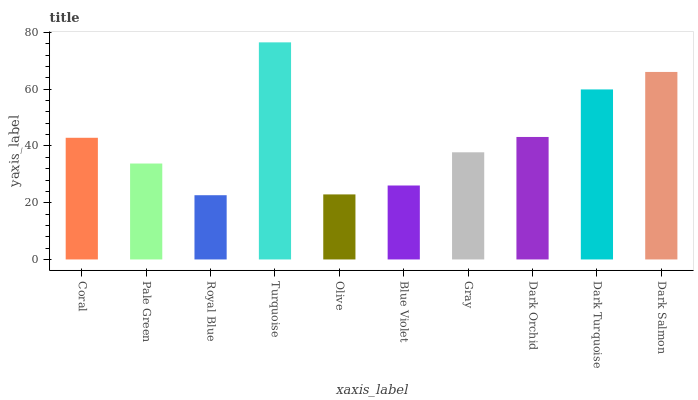Is Royal Blue the minimum?
Answer yes or no. Yes. Is Turquoise the maximum?
Answer yes or no. Yes. Is Pale Green the minimum?
Answer yes or no. No. Is Pale Green the maximum?
Answer yes or no. No. Is Coral greater than Pale Green?
Answer yes or no. Yes. Is Pale Green less than Coral?
Answer yes or no. Yes. Is Pale Green greater than Coral?
Answer yes or no. No. Is Coral less than Pale Green?
Answer yes or no. No. Is Coral the high median?
Answer yes or no. Yes. Is Gray the low median?
Answer yes or no. Yes. Is Turquoise the high median?
Answer yes or no. No. Is Pale Green the low median?
Answer yes or no. No. 